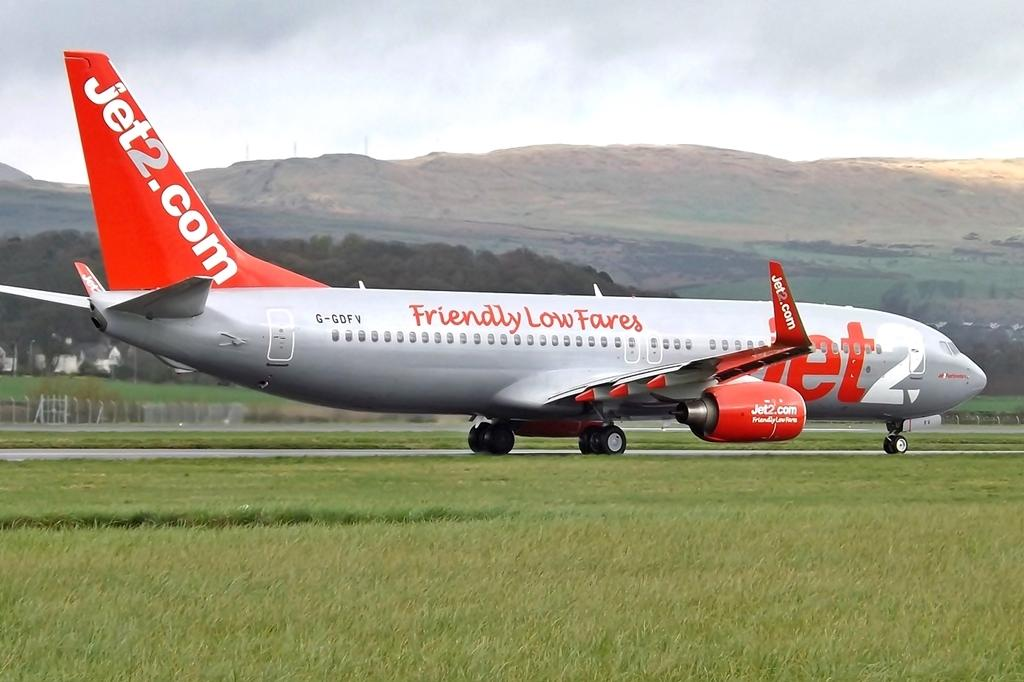What is the main subject of the image? The main subject of the image is an airplane on the ground. What can be seen beside the airplane? There is grass beside the ground where the airplane is located. What structures are visible in the image? There is a fence and houses in the image. What type of natural elements can be seen in the image? There are trees and mountains visible in the image. What is visible in the background of the image? The sky is visible in the background. What type of juice is being served by the servant in the image? There is no servant or juice present in the image. What is the visibility like due to the fog in the image? There is no fog present in the image; the sky is visible in the background. 